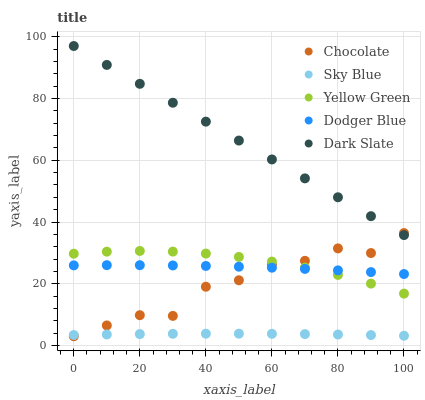Does Sky Blue have the minimum area under the curve?
Answer yes or no. Yes. Does Dark Slate have the maximum area under the curve?
Answer yes or no. Yes. Does Dodger Blue have the minimum area under the curve?
Answer yes or no. No. Does Dodger Blue have the maximum area under the curve?
Answer yes or no. No. Is Dark Slate the smoothest?
Answer yes or no. Yes. Is Chocolate the roughest?
Answer yes or no. Yes. Is Dodger Blue the smoothest?
Answer yes or no. No. Is Dodger Blue the roughest?
Answer yes or no. No. Does Chocolate have the lowest value?
Answer yes or no. Yes. Does Dodger Blue have the lowest value?
Answer yes or no. No. Does Dark Slate have the highest value?
Answer yes or no. Yes. Does Dodger Blue have the highest value?
Answer yes or no. No. Is Sky Blue less than Dodger Blue?
Answer yes or no. Yes. Is Dark Slate greater than Yellow Green?
Answer yes or no. Yes. Does Chocolate intersect Dark Slate?
Answer yes or no. Yes. Is Chocolate less than Dark Slate?
Answer yes or no. No. Is Chocolate greater than Dark Slate?
Answer yes or no. No. Does Sky Blue intersect Dodger Blue?
Answer yes or no. No. 